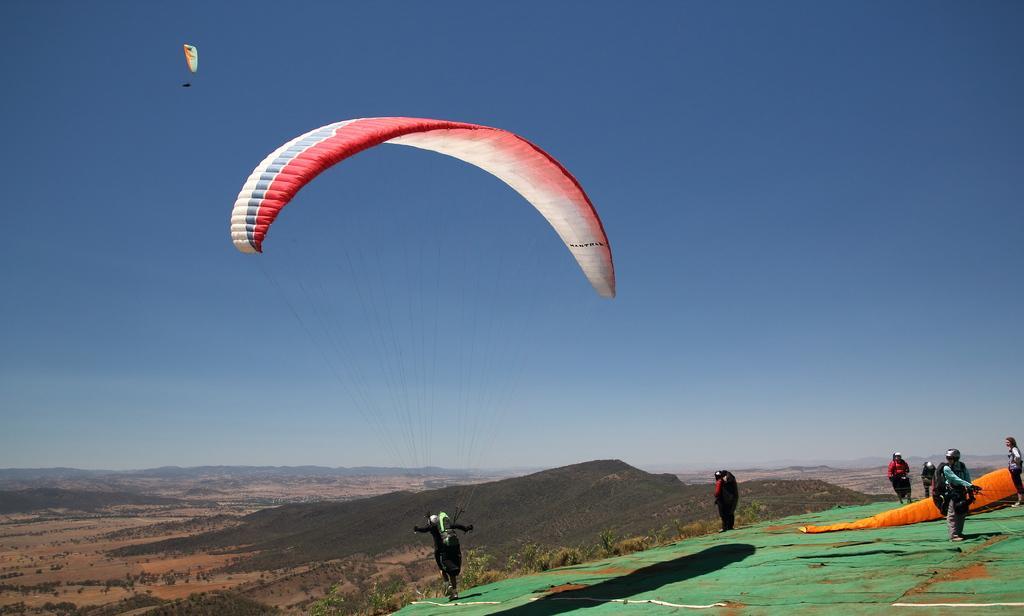Could you give a brief overview of what you see in this image? In this image we can see few people. There are few parachutes in the image. There are few hills in the image. There are many trees in the image. We can see the sky in the image. 